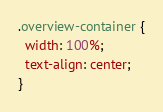Convert code to text. <code><loc_0><loc_0><loc_500><loc_500><_CSS_>.overview-container {
  width: 100%;
  text-align: center;
}
</code> 